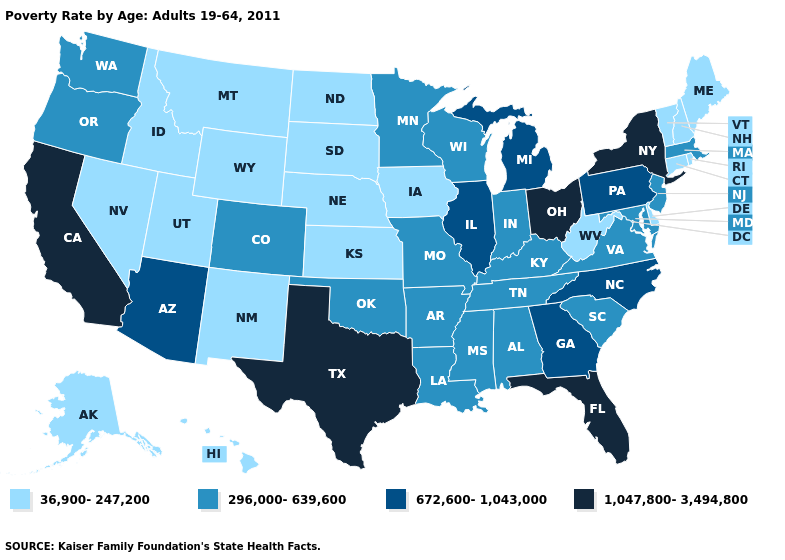How many symbols are there in the legend?
Short answer required. 4. What is the value of Rhode Island?
Give a very brief answer. 36,900-247,200. Name the states that have a value in the range 672,600-1,043,000?
Keep it brief. Arizona, Georgia, Illinois, Michigan, North Carolina, Pennsylvania. Among the states that border Virginia , which have the highest value?
Write a very short answer. North Carolina. Among the states that border Pennsylvania , does Ohio have the lowest value?
Answer briefly. No. What is the value of Nebraska?
Write a very short answer. 36,900-247,200. Name the states that have a value in the range 296,000-639,600?
Concise answer only. Alabama, Arkansas, Colorado, Indiana, Kentucky, Louisiana, Maryland, Massachusetts, Minnesota, Mississippi, Missouri, New Jersey, Oklahoma, Oregon, South Carolina, Tennessee, Virginia, Washington, Wisconsin. Among the states that border South Dakota , does Montana have the lowest value?
Answer briefly. Yes. Does the first symbol in the legend represent the smallest category?
Be succinct. Yes. Does Maryland have the highest value in the USA?
Be succinct. No. Does Florida have the highest value in the South?
Quick response, please. Yes. Among the states that border Florida , does Georgia have the lowest value?
Keep it brief. No. Name the states that have a value in the range 1,047,800-3,494,800?
Keep it brief. California, Florida, New York, Ohio, Texas. Does Mississippi have a higher value than Kansas?
Short answer required. Yes. 